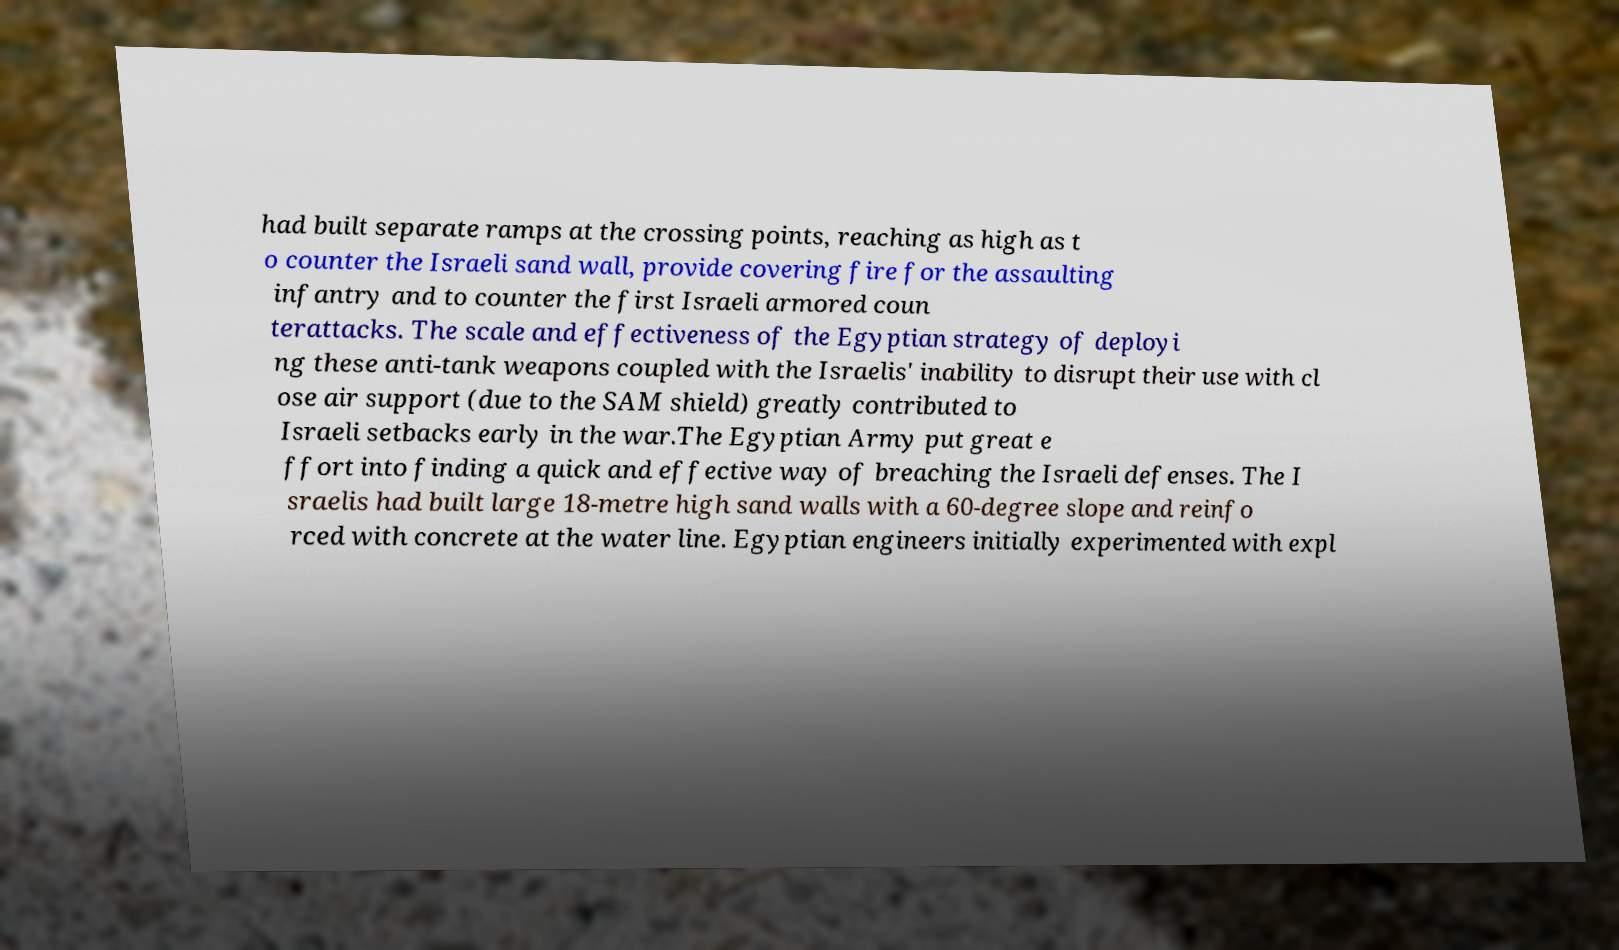Please identify and transcribe the text found in this image. had built separate ramps at the crossing points, reaching as high as t o counter the Israeli sand wall, provide covering fire for the assaulting infantry and to counter the first Israeli armored coun terattacks. The scale and effectiveness of the Egyptian strategy of deployi ng these anti-tank weapons coupled with the Israelis' inability to disrupt their use with cl ose air support (due to the SAM shield) greatly contributed to Israeli setbacks early in the war.The Egyptian Army put great e ffort into finding a quick and effective way of breaching the Israeli defenses. The I sraelis had built large 18-metre high sand walls with a 60-degree slope and reinfo rced with concrete at the water line. Egyptian engineers initially experimented with expl 